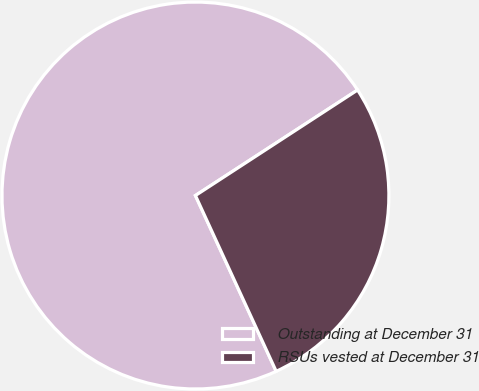<chart> <loc_0><loc_0><loc_500><loc_500><pie_chart><fcel>Outstanding at December 31<fcel>RSUs vested at December 31<nl><fcel>72.67%<fcel>27.33%<nl></chart> 